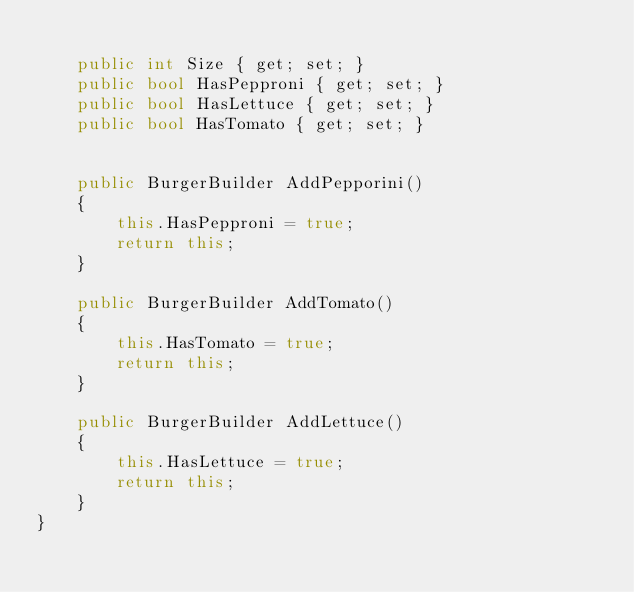<code> <loc_0><loc_0><loc_500><loc_500><_C#_>
    public int Size { get; set; }
    public bool HasPepproni { get; set; }
    public bool HasLettuce { get; set; }
    public bool HasTomato { get; set; }

    
    public BurgerBuilder AddPepporini()
    {
        this.HasPepproni = true;
        return this;
    }

    public BurgerBuilder AddTomato()
    {
        this.HasTomato = true;
        return this;
    }

    public BurgerBuilder AddLettuce()
    {
        this.HasLettuce = true;
        return this;
    }
}</code> 